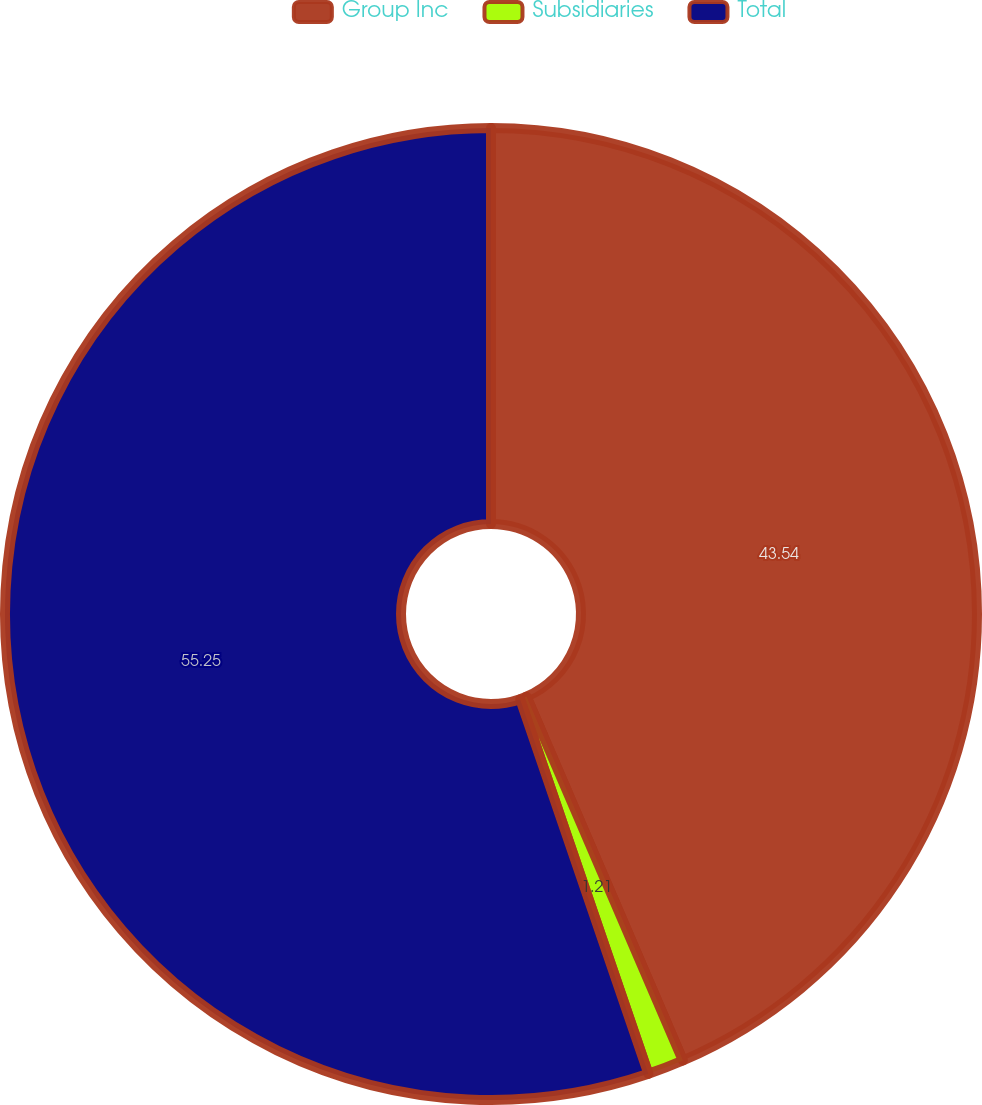Convert chart. <chart><loc_0><loc_0><loc_500><loc_500><pie_chart><fcel>Group Inc<fcel>Subsidiaries<fcel>Total<nl><fcel>43.54%<fcel>1.21%<fcel>55.25%<nl></chart> 